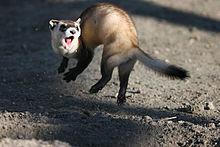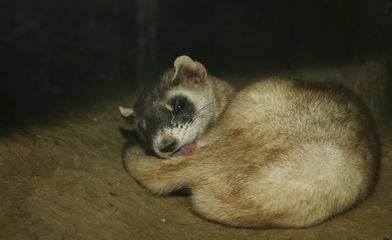The first image is the image on the left, the second image is the image on the right. For the images displayed, is the sentence "The right image contains exactly one ferret curled up on the floor." factually correct? Answer yes or no. Yes. The first image is the image on the left, the second image is the image on the right. Analyze the images presented: Is the assertion "One image shows a single ferret with its head raised and gazing leftward." valid? Answer yes or no. No. 